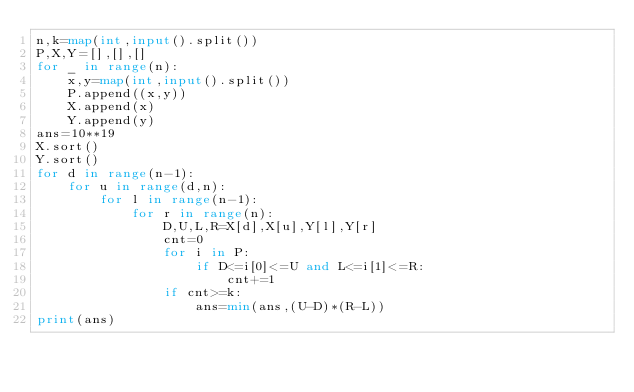Convert code to text. <code><loc_0><loc_0><loc_500><loc_500><_Python_>n,k=map(int,input().split())
P,X,Y=[],[],[]
for _ in range(n):
    x,y=map(int,input().split())
    P.append((x,y))
    X.append(x)
    Y.append(y)
ans=10**19
X.sort()
Y.sort()
for d in range(n-1):
    for u in range(d,n):
        for l in range(n-1):
            for r in range(n):
                D,U,L,R=X[d],X[u],Y[l],Y[r]
                cnt=0
                for i in P:
                    if D<=i[0]<=U and L<=i[1]<=R:
                        cnt+=1
                if cnt>=k:
                    ans=min(ans,(U-D)*(R-L))
print(ans)</code> 